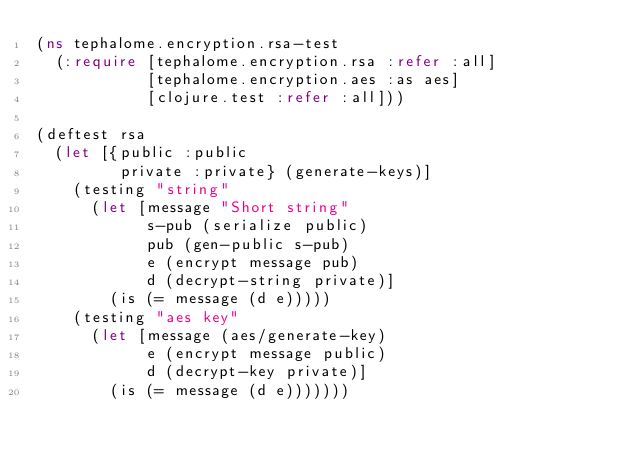Convert code to text. <code><loc_0><loc_0><loc_500><loc_500><_Clojure_>(ns tephalome.encryption.rsa-test
  (:require [tephalome.encryption.rsa :refer :all]
            [tephalome.encryption.aes :as aes]
            [clojure.test :refer :all]))

(deftest rsa
  (let [{public :public
         private :private} (generate-keys)]
    (testing "string"
      (let [message "Short string"
            s-pub (serialize public)
            pub (gen-public s-pub)
            e (encrypt message pub)
            d (decrypt-string private)]
        (is (= message (d e)))))
    (testing "aes key"
      (let [message (aes/generate-key)
            e (encrypt message public)
            d (decrypt-key private)]
        (is (= message (d e)))))))
</code> 